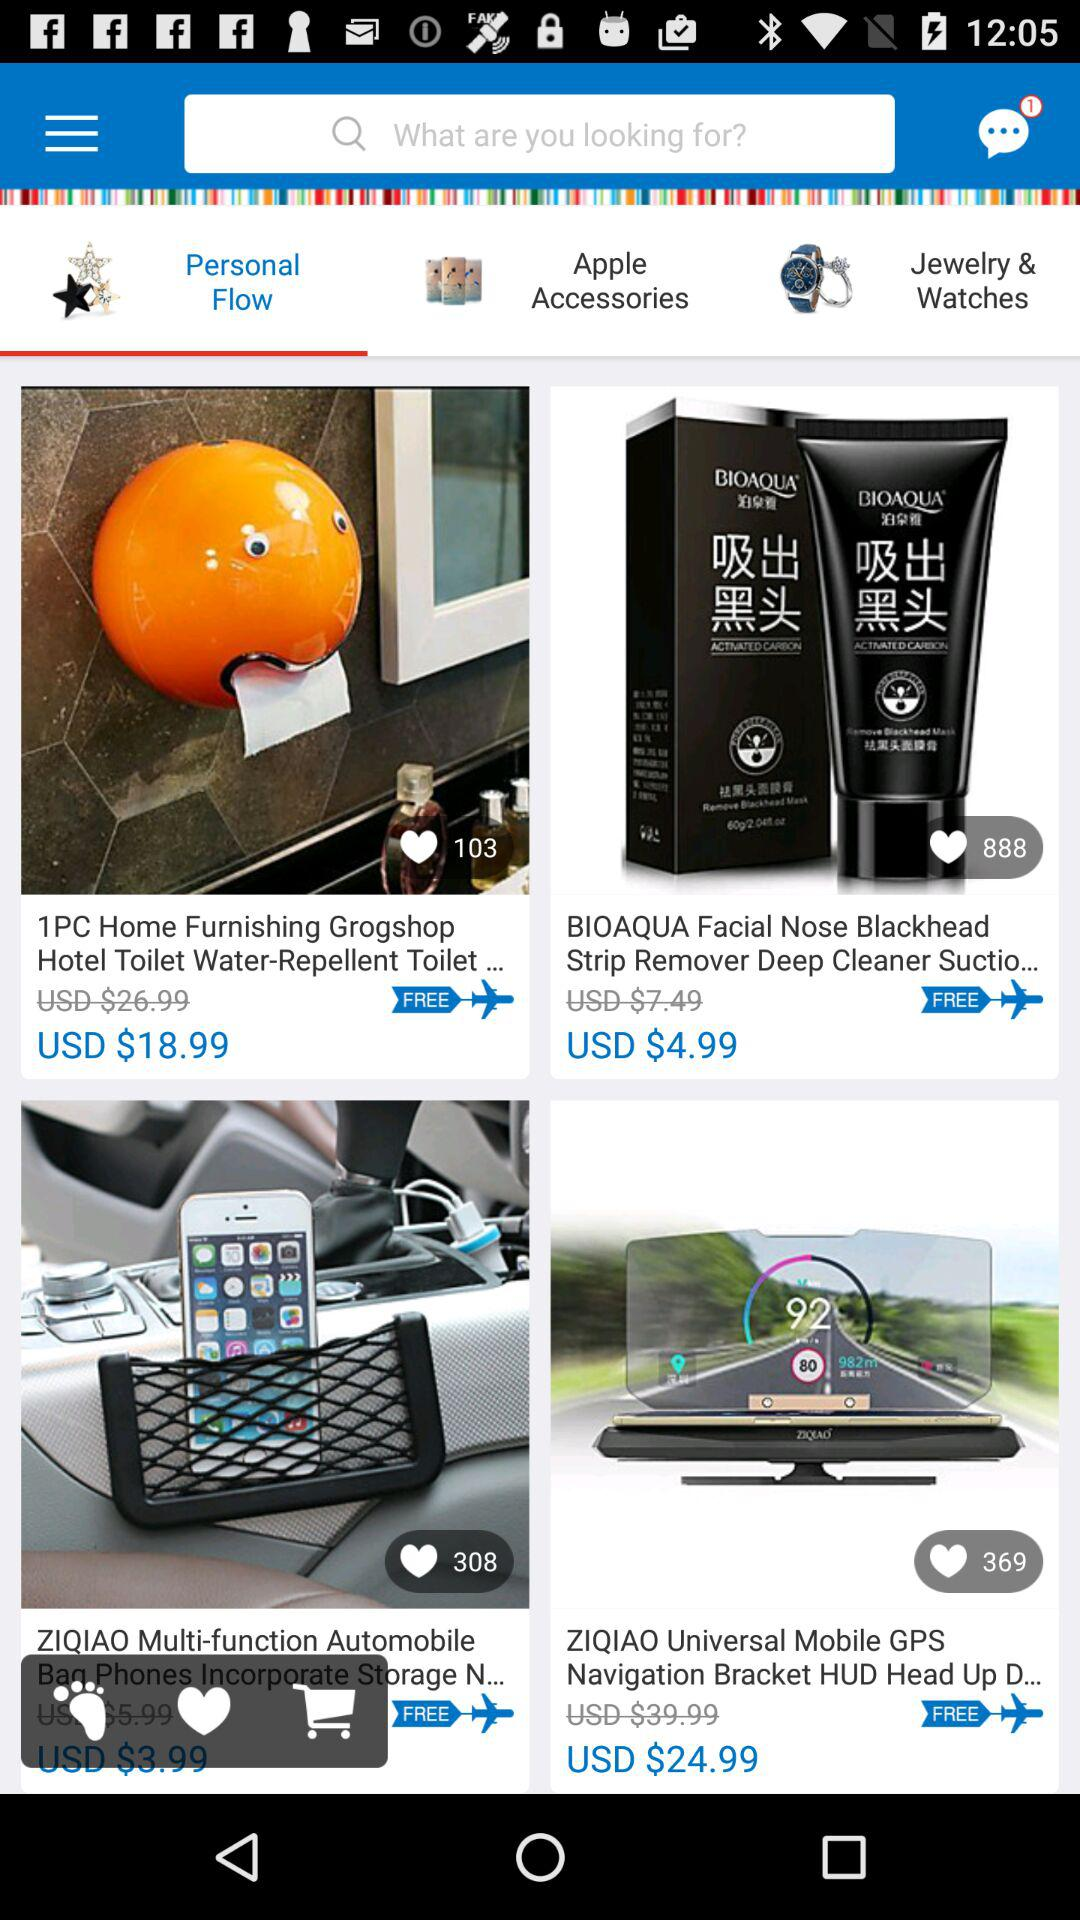What is the cost of the "BIOAQUA Facial Nose Blackhead Strip Remover Deep Cleaner Suctio..."? The cost of the "BIOAQUA Facial Nose Blackhead Strip Remover Deep Cleaner Suctio..." is USD $4.99. 